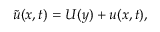<formula> <loc_0><loc_0><loc_500><loc_500>\tilde { u } ( x , t ) = U ( y ) + u ( x , t ) ,</formula> 